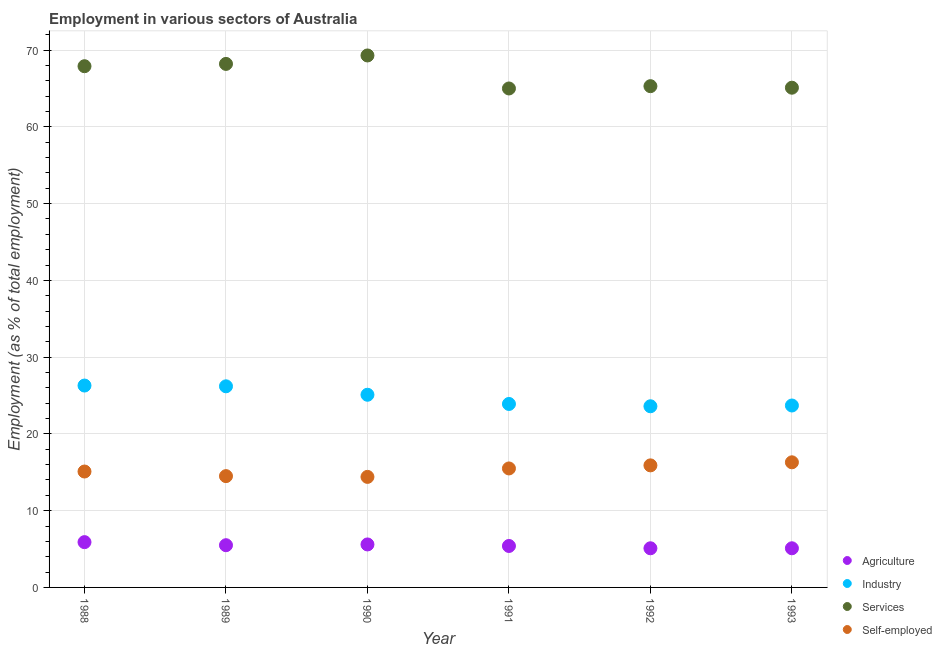How many different coloured dotlines are there?
Give a very brief answer. 4. What is the percentage of self employed workers in 1993?
Offer a terse response. 16.3. Across all years, what is the maximum percentage of self employed workers?
Make the answer very short. 16.3. Across all years, what is the minimum percentage of self employed workers?
Offer a terse response. 14.4. In which year was the percentage of self employed workers minimum?
Your answer should be very brief. 1990. What is the total percentage of workers in agriculture in the graph?
Keep it short and to the point. 32.6. What is the difference between the percentage of self employed workers in 1991 and that in 1993?
Provide a succinct answer. -0.8. What is the difference between the percentage of workers in industry in 1991 and the percentage of self employed workers in 1992?
Offer a very short reply. 8. What is the average percentage of workers in agriculture per year?
Give a very brief answer. 5.43. In the year 1991, what is the difference between the percentage of workers in agriculture and percentage of workers in services?
Your response must be concise. -59.6. In how many years, is the percentage of workers in services greater than 40 %?
Make the answer very short. 6. What is the ratio of the percentage of self employed workers in 1991 to that in 1993?
Your answer should be compact. 0.95. Is the difference between the percentage of workers in services in 1989 and 1990 greater than the difference between the percentage of self employed workers in 1989 and 1990?
Provide a short and direct response. No. What is the difference between the highest and the second highest percentage of self employed workers?
Ensure brevity in your answer.  0.4. What is the difference between the highest and the lowest percentage of workers in industry?
Provide a succinct answer. 2.7. In how many years, is the percentage of workers in agriculture greater than the average percentage of workers in agriculture taken over all years?
Your response must be concise. 3. Is the sum of the percentage of self employed workers in 1992 and 1993 greater than the maximum percentage of workers in services across all years?
Keep it short and to the point. No. Is it the case that in every year, the sum of the percentage of self employed workers and percentage of workers in agriculture is greater than the sum of percentage of workers in industry and percentage of workers in services?
Ensure brevity in your answer.  No. Is it the case that in every year, the sum of the percentage of workers in agriculture and percentage of workers in industry is greater than the percentage of workers in services?
Your answer should be very brief. No. Does the percentage of workers in services monotonically increase over the years?
Offer a very short reply. No. Is the percentage of workers in services strictly greater than the percentage of self employed workers over the years?
Your response must be concise. Yes. What is the difference between two consecutive major ticks on the Y-axis?
Ensure brevity in your answer.  10. Are the values on the major ticks of Y-axis written in scientific E-notation?
Keep it short and to the point. No. Where does the legend appear in the graph?
Your response must be concise. Bottom right. How are the legend labels stacked?
Your response must be concise. Vertical. What is the title of the graph?
Your response must be concise. Employment in various sectors of Australia. What is the label or title of the X-axis?
Give a very brief answer. Year. What is the label or title of the Y-axis?
Offer a terse response. Employment (as % of total employment). What is the Employment (as % of total employment) of Agriculture in 1988?
Offer a very short reply. 5.9. What is the Employment (as % of total employment) in Industry in 1988?
Your answer should be very brief. 26.3. What is the Employment (as % of total employment) of Services in 1988?
Offer a terse response. 67.9. What is the Employment (as % of total employment) in Self-employed in 1988?
Provide a short and direct response. 15.1. What is the Employment (as % of total employment) in Industry in 1989?
Your response must be concise. 26.2. What is the Employment (as % of total employment) in Services in 1989?
Ensure brevity in your answer.  68.2. What is the Employment (as % of total employment) in Agriculture in 1990?
Your answer should be very brief. 5.6. What is the Employment (as % of total employment) in Industry in 1990?
Offer a very short reply. 25.1. What is the Employment (as % of total employment) in Services in 1990?
Offer a terse response. 69.3. What is the Employment (as % of total employment) in Self-employed in 1990?
Keep it short and to the point. 14.4. What is the Employment (as % of total employment) of Agriculture in 1991?
Your answer should be compact. 5.4. What is the Employment (as % of total employment) of Industry in 1991?
Provide a short and direct response. 23.9. What is the Employment (as % of total employment) in Self-employed in 1991?
Your answer should be compact. 15.5. What is the Employment (as % of total employment) of Agriculture in 1992?
Provide a short and direct response. 5.1. What is the Employment (as % of total employment) of Industry in 1992?
Provide a short and direct response. 23.6. What is the Employment (as % of total employment) in Services in 1992?
Your response must be concise. 65.3. What is the Employment (as % of total employment) of Self-employed in 1992?
Your answer should be compact. 15.9. What is the Employment (as % of total employment) in Agriculture in 1993?
Your answer should be very brief. 5.1. What is the Employment (as % of total employment) in Industry in 1993?
Provide a succinct answer. 23.7. What is the Employment (as % of total employment) in Services in 1993?
Make the answer very short. 65.1. What is the Employment (as % of total employment) of Self-employed in 1993?
Your answer should be compact. 16.3. Across all years, what is the maximum Employment (as % of total employment) of Agriculture?
Keep it short and to the point. 5.9. Across all years, what is the maximum Employment (as % of total employment) in Industry?
Make the answer very short. 26.3. Across all years, what is the maximum Employment (as % of total employment) in Services?
Keep it short and to the point. 69.3. Across all years, what is the maximum Employment (as % of total employment) in Self-employed?
Your answer should be compact. 16.3. Across all years, what is the minimum Employment (as % of total employment) in Agriculture?
Ensure brevity in your answer.  5.1. Across all years, what is the minimum Employment (as % of total employment) in Industry?
Your answer should be compact. 23.6. Across all years, what is the minimum Employment (as % of total employment) of Self-employed?
Offer a very short reply. 14.4. What is the total Employment (as % of total employment) in Agriculture in the graph?
Your response must be concise. 32.6. What is the total Employment (as % of total employment) of Industry in the graph?
Ensure brevity in your answer.  148.8. What is the total Employment (as % of total employment) of Services in the graph?
Make the answer very short. 400.8. What is the total Employment (as % of total employment) of Self-employed in the graph?
Offer a very short reply. 91.7. What is the difference between the Employment (as % of total employment) of Agriculture in 1988 and that in 1989?
Ensure brevity in your answer.  0.4. What is the difference between the Employment (as % of total employment) in Services in 1988 and that in 1989?
Your answer should be compact. -0.3. What is the difference between the Employment (as % of total employment) of Agriculture in 1988 and that in 1990?
Provide a succinct answer. 0.3. What is the difference between the Employment (as % of total employment) in Industry in 1988 and that in 1990?
Offer a terse response. 1.2. What is the difference between the Employment (as % of total employment) of Services in 1988 and that in 1990?
Ensure brevity in your answer.  -1.4. What is the difference between the Employment (as % of total employment) in Self-employed in 1988 and that in 1992?
Provide a succinct answer. -0.8. What is the difference between the Employment (as % of total employment) of Agriculture in 1988 and that in 1993?
Offer a terse response. 0.8. What is the difference between the Employment (as % of total employment) of Industry in 1988 and that in 1993?
Offer a very short reply. 2.6. What is the difference between the Employment (as % of total employment) of Services in 1988 and that in 1993?
Your response must be concise. 2.8. What is the difference between the Employment (as % of total employment) in Agriculture in 1989 and that in 1990?
Provide a short and direct response. -0.1. What is the difference between the Employment (as % of total employment) of Services in 1989 and that in 1990?
Give a very brief answer. -1.1. What is the difference between the Employment (as % of total employment) in Agriculture in 1989 and that in 1991?
Offer a terse response. 0.1. What is the difference between the Employment (as % of total employment) of Industry in 1989 and that in 1991?
Provide a short and direct response. 2.3. What is the difference between the Employment (as % of total employment) of Self-employed in 1989 and that in 1991?
Ensure brevity in your answer.  -1. What is the difference between the Employment (as % of total employment) in Agriculture in 1989 and that in 1992?
Your answer should be compact. 0.4. What is the difference between the Employment (as % of total employment) of Industry in 1989 and that in 1992?
Your answer should be very brief. 2.6. What is the difference between the Employment (as % of total employment) in Self-employed in 1989 and that in 1992?
Your answer should be very brief. -1.4. What is the difference between the Employment (as % of total employment) of Self-employed in 1989 and that in 1993?
Provide a succinct answer. -1.8. What is the difference between the Employment (as % of total employment) of Industry in 1990 and that in 1991?
Your answer should be very brief. 1.2. What is the difference between the Employment (as % of total employment) of Industry in 1990 and that in 1992?
Ensure brevity in your answer.  1.5. What is the difference between the Employment (as % of total employment) of Services in 1990 and that in 1992?
Ensure brevity in your answer.  4. What is the difference between the Employment (as % of total employment) of Industry in 1990 and that in 1993?
Your answer should be compact. 1.4. What is the difference between the Employment (as % of total employment) of Services in 1990 and that in 1993?
Offer a very short reply. 4.2. What is the difference between the Employment (as % of total employment) of Industry in 1991 and that in 1993?
Provide a succinct answer. 0.2. What is the difference between the Employment (as % of total employment) of Services in 1991 and that in 1993?
Offer a terse response. -0.1. What is the difference between the Employment (as % of total employment) in Agriculture in 1992 and that in 1993?
Ensure brevity in your answer.  0. What is the difference between the Employment (as % of total employment) of Services in 1992 and that in 1993?
Keep it short and to the point. 0.2. What is the difference between the Employment (as % of total employment) in Agriculture in 1988 and the Employment (as % of total employment) in Industry in 1989?
Make the answer very short. -20.3. What is the difference between the Employment (as % of total employment) of Agriculture in 1988 and the Employment (as % of total employment) of Services in 1989?
Your response must be concise. -62.3. What is the difference between the Employment (as % of total employment) of Industry in 1988 and the Employment (as % of total employment) of Services in 1989?
Offer a terse response. -41.9. What is the difference between the Employment (as % of total employment) in Services in 1988 and the Employment (as % of total employment) in Self-employed in 1989?
Give a very brief answer. 53.4. What is the difference between the Employment (as % of total employment) in Agriculture in 1988 and the Employment (as % of total employment) in Industry in 1990?
Keep it short and to the point. -19.2. What is the difference between the Employment (as % of total employment) in Agriculture in 1988 and the Employment (as % of total employment) in Services in 1990?
Your response must be concise. -63.4. What is the difference between the Employment (as % of total employment) in Agriculture in 1988 and the Employment (as % of total employment) in Self-employed in 1990?
Your response must be concise. -8.5. What is the difference between the Employment (as % of total employment) in Industry in 1988 and the Employment (as % of total employment) in Services in 1990?
Give a very brief answer. -43. What is the difference between the Employment (as % of total employment) in Industry in 1988 and the Employment (as % of total employment) in Self-employed in 1990?
Provide a succinct answer. 11.9. What is the difference between the Employment (as % of total employment) in Services in 1988 and the Employment (as % of total employment) in Self-employed in 1990?
Your answer should be very brief. 53.5. What is the difference between the Employment (as % of total employment) in Agriculture in 1988 and the Employment (as % of total employment) in Services in 1991?
Keep it short and to the point. -59.1. What is the difference between the Employment (as % of total employment) in Industry in 1988 and the Employment (as % of total employment) in Services in 1991?
Your response must be concise. -38.7. What is the difference between the Employment (as % of total employment) of Industry in 1988 and the Employment (as % of total employment) of Self-employed in 1991?
Keep it short and to the point. 10.8. What is the difference between the Employment (as % of total employment) of Services in 1988 and the Employment (as % of total employment) of Self-employed in 1991?
Your response must be concise. 52.4. What is the difference between the Employment (as % of total employment) of Agriculture in 1988 and the Employment (as % of total employment) of Industry in 1992?
Give a very brief answer. -17.7. What is the difference between the Employment (as % of total employment) in Agriculture in 1988 and the Employment (as % of total employment) in Services in 1992?
Give a very brief answer. -59.4. What is the difference between the Employment (as % of total employment) of Agriculture in 1988 and the Employment (as % of total employment) of Self-employed in 1992?
Make the answer very short. -10. What is the difference between the Employment (as % of total employment) of Industry in 1988 and the Employment (as % of total employment) of Services in 1992?
Ensure brevity in your answer.  -39. What is the difference between the Employment (as % of total employment) of Industry in 1988 and the Employment (as % of total employment) of Self-employed in 1992?
Keep it short and to the point. 10.4. What is the difference between the Employment (as % of total employment) of Agriculture in 1988 and the Employment (as % of total employment) of Industry in 1993?
Keep it short and to the point. -17.8. What is the difference between the Employment (as % of total employment) of Agriculture in 1988 and the Employment (as % of total employment) of Services in 1993?
Provide a short and direct response. -59.2. What is the difference between the Employment (as % of total employment) of Agriculture in 1988 and the Employment (as % of total employment) of Self-employed in 1993?
Offer a terse response. -10.4. What is the difference between the Employment (as % of total employment) in Industry in 1988 and the Employment (as % of total employment) in Services in 1993?
Provide a succinct answer. -38.8. What is the difference between the Employment (as % of total employment) of Services in 1988 and the Employment (as % of total employment) of Self-employed in 1993?
Give a very brief answer. 51.6. What is the difference between the Employment (as % of total employment) of Agriculture in 1989 and the Employment (as % of total employment) of Industry in 1990?
Ensure brevity in your answer.  -19.6. What is the difference between the Employment (as % of total employment) in Agriculture in 1989 and the Employment (as % of total employment) in Services in 1990?
Your answer should be compact. -63.8. What is the difference between the Employment (as % of total employment) in Industry in 1989 and the Employment (as % of total employment) in Services in 1990?
Keep it short and to the point. -43.1. What is the difference between the Employment (as % of total employment) in Industry in 1989 and the Employment (as % of total employment) in Self-employed in 1990?
Give a very brief answer. 11.8. What is the difference between the Employment (as % of total employment) of Services in 1989 and the Employment (as % of total employment) of Self-employed in 1990?
Give a very brief answer. 53.8. What is the difference between the Employment (as % of total employment) of Agriculture in 1989 and the Employment (as % of total employment) of Industry in 1991?
Provide a succinct answer. -18.4. What is the difference between the Employment (as % of total employment) of Agriculture in 1989 and the Employment (as % of total employment) of Services in 1991?
Provide a succinct answer. -59.5. What is the difference between the Employment (as % of total employment) in Industry in 1989 and the Employment (as % of total employment) in Services in 1991?
Keep it short and to the point. -38.8. What is the difference between the Employment (as % of total employment) in Industry in 1989 and the Employment (as % of total employment) in Self-employed in 1991?
Your answer should be compact. 10.7. What is the difference between the Employment (as % of total employment) in Services in 1989 and the Employment (as % of total employment) in Self-employed in 1991?
Provide a succinct answer. 52.7. What is the difference between the Employment (as % of total employment) of Agriculture in 1989 and the Employment (as % of total employment) of Industry in 1992?
Provide a succinct answer. -18.1. What is the difference between the Employment (as % of total employment) of Agriculture in 1989 and the Employment (as % of total employment) of Services in 1992?
Give a very brief answer. -59.8. What is the difference between the Employment (as % of total employment) in Industry in 1989 and the Employment (as % of total employment) in Services in 1992?
Offer a very short reply. -39.1. What is the difference between the Employment (as % of total employment) of Services in 1989 and the Employment (as % of total employment) of Self-employed in 1992?
Make the answer very short. 52.3. What is the difference between the Employment (as % of total employment) in Agriculture in 1989 and the Employment (as % of total employment) in Industry in 1993?
Your response must be concise. -18.2. What is the difference between the Employment (as % of total employment) of Agriculture in 1989 and the Employment (as % of total employment) of Services in 1993?
Keep it short and to the point. -59.6. What is the difference between the Employment (as % of total employment) in Industry in 1989 and the Employment (as % of total employment) in Services in 1993?
Your response must be concise. -38.9. What is the difference between the Employment (as % of total employment) of Industry in 1989 and the Employment (as % of total employment) of Self-employed in 1993?
Provide a succinct answer. 9.9. What is the difference between the Employment (as % of total employment) in Services in 1989 and the Employment (as % of total employment) in Self-employed in 1993?
Give a very brief answer. 51.9. What is the difference between the Employment (as % of total employment) in Agriculture in 1990 and the Employment (as % of total employment) in Industry in 1991?
Provide a short and direct response. -18.3. What is the difference between the Employment (as % of total employment) of Agriculture in 1990 and the Employment (as % of total employment) of Services in 1991?
Your answer should be very brief. -59.4. What is the difference between the Employment (as % of total employment) in Industry in 1990 and the Employment (as % of total employment) in Services in 1991?
Your answer should be compact. -39.9. What is the difference between the Employment (as % of total employment) of Services in 1990 and the Employment (as % of total employment) of Self-employed in 1991?
Provide a short and direct response. 53.8. What is the difference between the Employment (as % of total employment) of Agriculture in 1990 and the Employment (as % of total employment) of Services in 1992?
Keep it short and to the point. -59.7. What is the difference between the Employment (as % of total employment) in Agriculture in 1990 and the Employment (as % of total employment) in Self-employed in 1992?
Ensure brevity in your answer.  -10.3. What is the difference between the Employment (as % of total employment) of Industry in 1990 and the Employment (as % of total employment) of Services in 1992?
Give a very brief answer. -40.2. What is the difference between the Employment (as % of total employment) of Services in 1990 and the Employment (as % of total employment) of Self-employed in 1992?
Make the answer very short. 53.4. What is the difference between the Employment (as % of total employment) of Agriculture in 1990 and the Employment (as % of total employment) of Industry in 1993?
Your answer should be very brief. -18.1. What is the difference between the Employment (as % of total employment) of Agriculture in 1990 and the Employment (as % of total employment) of Services in 1993?
Offer a very short reply. -59.5. What is the difference between the Employment (as % of total employment) of Agriculture in 1990 and the Employment (as % of total employment) of Self-employed in 1993?
Offer a very short reply. -10.7. What is the difference between the Employment (as % of total employment) of Industry in 1990 and the Employment (as % of total employment) of Services in 1993?
Provide a short and direct response. -40. What is the difference between the Employment (as % of total employment) in Agriculture in 1991 and the Employment (as % of total employment) in Industry in 1992?
Ensure brevity in your answer.  -18.2. What is the difference between the Employment (as % of total employment) of Agriculture in 1991 and the Employment (as % of total employment) of Services in 1992?
Provide a succinct answer. -59.9. What is the difference between the Employment (as % of total employment) in Industry in 1991 and the Employment (as % of total employment) in Services in 1992?
Provide a succinct answer. -41.4. What is the difference between the Employment (as % of total employment) in Industry in 1991 and the Employment (as % of total employment) in Self-employed in 1992?
Your response must be concise. 8. What is the difference between the Employment (as % of total employment) of Services in 1991 and the Employment (as % of total employment) of Self-employed in 1992?
Give a very brief answer. 49.1. What is the difference between the Employment (as % of total employment) of Agriculture in 1991 and the Employment (as % of total employment) of Industry in 1993?
Offer a very short reply. -18.3. What is the difference between the Employment (as % of total employment) of Agriculture in 1991 and the Employment (as % of total employment) of Services in 1993?
Make the answer very short. -59.7. What is the difference between the Employment (as % of total employment) in Agriculture in 1991 and the Employment (as % of total employment) in Self-employed in 1993?
Offer a terse response. -10.9. What is the difference between the Employment (as % of total employment) of Industry in 1991 and the Employment (as % of total employment) of Services in 1993?
Provide a short and direct response. -41.2. What is the difference between the Employment (as % of total employment) in Services in 1991 and the Employment (as % of total employment) in Self-employed in 1993?
Offer a very short reply. 48.7. What is the difference between the Employment (as % of total employment) in Agriculture in 1992 and the Employment (as % of total employment) in Industry in 1993?
Keep it short and to the point. -18.6. What is the difference between the Employment (as % of total employment) of Agriculture in 1992 and the Employment (as % of total employment) of Services in 1993?
Offer a very short reply. -60. What is the difference between the Employment (as % of total employment) in Agriculture in 1992 and the Employment (as % of total employment) in Self-employed in 1993?
Provide a short and direct response. -11.2. What is the difference between the Employment (as % of total employment) in Industry in 1992 and the Employment (as % of total employment) in Services in 1993?
Keep it short and to the point. -41.5. What is the difference between the Employment (as % of total employment) in Industry in 1992 and the Employment (as % of total employment) in Self-employed in 1993?
Ensure brevity in your answer.  7.3. What is the average Employment (as % of total employment) in Agriculture per year?
Give a very brief answer. 5.43. What is the average Employment (as % of total employment) in Industry per year?
Your response must be concise. 24.8. What is the average Employment (as % of total employment) of Services per year?
Keep it short and to the point. 66.8. What is the average Employment (as % of total employment) of Self-employed per year?
Provide a short and direct response. 15.28. In the year 1988, what is the difference between the Employment (as % of total employment) in Agriculture and Employment (as % of total employment) in Industry?
Offer a very short reply. -20.4. In the year 1988, what is the difference between the Employment (as % of total employment) of Agriculture and Employment (as % of total employment) of Services?
Your answer should be compact. -62. In the year 1988, what is the difference between the Employment (as % of total employment) of Industry and Employment (as % of total employment) of Services?
Make the answer very short. -41.6. In the year 1988, what is the difference between the Employment (as % of total employment) of Industry and Employment (as % of total employment) of Self-employed?
Provide a succinct answer. 11.2. In the year 1988, what is the difference between the Employment (as % of total employment) in Services and Employment (as % of total employment) in Self-employed?
Your response must be concise. 52.8. In the year 1989, what is the difference between the Employment (as % of total employment) of Agriculture and Employment (as % of total employment) of Industry?
Your response must be concise. -20.7. In the year 1989, what is the difference between the Employment (as % of total employment) in Agriculture and Employment (as % of total employment) in Services?
Your answer should be compact. -62.7. In the year 1989, what is the difference between the Employment (as % of total employment) in Agriculture and Employment (as % of total employment) in Self-employed?
Your answer should be compact. -9. In the year 1989, what is the difference between the Employment (as % of total employment) in Industry and Employment (as % of total employment) in Services?
Your answer should be very brief. -42. In the year 1989, what is the difference between the Employment (as % of total employment) in Industry and Employment (as % of total employment) in Self-employed?
Your response must be concise. 11.7. In the year 1989, what is the difference between the Employment (as % of total employment) in Services and Employment (as % of total employment) in Self-employed?
Offer a very short reply. 53.7. In the year 1990, what is the difference between the Employment (as % of total employment) of Agriculture and Employment (as % of total employment) of Industry?
Your response must be concise. -19.5. In the year 1990, what is the difference between the Employment (as % of total employment) in Agriculture and Employment (as % of total employment) in Services?
Give a very brief answer. -63.7. In the year 1990, what is the difference between the Employment (as % of total employment) in Agriculture and Employment (as % of total employment) in Self-employed?
Ensure brevity in your answer.  -8.8. In the year 1990, what is the difference between the Employment (as % of total employment) of Industry and Employment (as % of total employment) of Services?
Your answer should be compact. -44.2. In the year 1990, what is the difference between the Employment (as % of total employment) in Industry and Employment (as % of total employment) in Self-employed?
Your answer should be compact. 10.7. In the year 1990, what is the difference between the Employment (as % of total employment) in Services and Employment (as % of total employment) in Self-employed?
Keep it short and to the point. 54.9. In the year 1991, what is the difference between the Employment (as % of total employment) in Agriculture and Employment (as % of total employment) in Industry?
Provide a succinct answer. -18.5. In the year 1991, what is the difference between the Employment (as % of total employment) of Agriculture and Employment (as % of total employment) of Services?
Your answer should be very brief. -59.6. In the year 1991, what is the difference between the Employment (as % of total employment) in Agriculture and Employment (as % of total employment) in Self-employed?
Make the answer very short. -10.1. In the year 1991, what is the difference between the Employment (as % of total employment) in Industry and Employment (as % of total employment) in Services?
Your answer should be very brief. -41.1. In the year 1991, what is the difference between the Employment (as % of total employment) in Industry and Employment (as % of total employment) in Self-employed?
Your response must be concise. 8.4. In the year 1991, what is the difference between the Employment (as % of total employment) of Services and Employment (as % of total employment) of Self-employed?
Keep it short and to the point. 49.5. In the year 1992, what is the difference between the Employment (as % of total employment) of Agriculture and Employment (as % of total employment) of Industry?
Make the answer very short. -18.5. In the year 1992, what is the difference between the Employment (as % of total employment) of Agriculture and Employment (as % of total employment) of Services?
Keep it short and to the point. -60.2. In the year 1992, what is the difference between the Employment (as % of total employment) in Agriculture and Employment (as % of total employment) in Self-employed?
Make the answer very short. -10.8. In the year 1992, what is the difference between the Employment (as % of total employment) in Industry and Employment (as % of total employment) in Services?
Provide a succinct answer. -41.7. In the year 1992, what is the difference between the Employment (as % of total employment) of Industry and Employment (as % of total employment) of Self-employed?
Your answer should be compact. 7.7. In the year 1992, what is the difference between the Employment (as % of total employment) in Services and Employment (as % of total employment) in Self-employed?
Your answer should be very brief. 49.4. In the year 1993, what is the difference between the Employment (as % of total employment) of Agriculture and Employment (as % of total employment) of Industry?
Your response must be concise. -18.6. In the year 1993, what is the difference between the Employment (as % of total employment) in Agriculture and Employment (as % of total employment) in Services?
Offer a terse response. -60. In the year 1993, what is the difference between the Employment (as % of total employment) in Industry and Employment (as % of total employment) in Services?
Your answer should be very brief. -41.4. In the year 1993, what is the difference between the Employment (as % of total employment) in Industry and Employment (as % of total employment) in Self-employed?
Provide a succinct answer. 7.4. In the year 1993, what is the difference between the Employment (as % of total employment) in Services and Employment (as % of total employment) in Self-employed?
Make the answer very short. 48.8. What is the ratio of the Employment (as % of total employment) in Agriculture in 1988 to that in 1989?
Provide a short and direct response. 1.07. What is the ratio of the Employment (as % of total employment) of Self-employed in 1988 to that in 1989?
Your answer should be very brief. 1.04. What is the ratio of the Employment (as % of total employment) of Agriculture in 1988 to that in 1990?
Give a very brief answer. 1.05. What is the ratio of the Employment (as % of total employment) of Industry in 1988 to that in 1990?
Give a very brief answer. 1.05. What is the ratio of the Employment (as % of total employment) in Services in 1988 to that in 1990?
Provide a short and direct response. 0.98. What is the ratio of the Employment (as % of total employment) of Self-employed in 1988 to that in 1990?
Give a very brief answer. 1.05. What is the ratio of the Employment (as % of total employment) of Agriculture in 1988 to that in 1991?
Offer a very short reply. 1.09. What is the ratio of the Employment (as % of total employment) in Industry in 1988 to that in 1991?
Offer a terse response. 1.1. What is the ratio of the Employment (as % of total employment) of Services in 1988 to that in 1991?
Offer a terse response. 1.04. What is the ratio of the Employment (as % of total employment) in Self-employed in 1988 to that in 1991?
Ensure brevity in your answer.  0.97. What is the ratio of the Employment (as % of total employment) in Agriculture in 1988 to that in 1992?
Your answer should be very brief. 1.16. What is the ratio of the Employment (as % of total employment) of Industry in 1988 to that in 1992?
Provide a short and direct response. 1.11. What is the ratio of the Employment (as % of total employment) in Services in 1988 to that in 1992?
Keep it short and to the point. 1.04. What is the ratio of the Employment (as % of total employment) in Self-employed in 1988 to that in 1992?
Your answer should be very brief. 0.95. What is the ratio of the Employment (as % of total employment) in Agriculture in 1988 to that in 1993?
Make the answer very short. 1.16. What is the ratio of the Employment (as % of total employment) of Industry in 1988 to that in 1993?
Provide a short and direct response. 1.11. What is the ratio of the Employment (as % of total employment) of Services in 1988 to that in 1993?
Your response must be concise. 1.04. What is the ratio of the Employment (as % of total employment) of Self-employed in 1988 to that in 1993?
Ensure brevity in your answer.  0.93. What is the ratio of the Employment (as % of total employment) of Agriculture in 1989 to that in 1990?
Keep it short and to the point. 0.98. What is the ratio of the Employment (as % of total employment) in Industry in 1989 to that in 1990?
Your answer should be very brief. 1.04. What is the ratio of the Employment (as % of total employment) in Services in 1989 to that in 1990?
Make the answer very short. 0.98. What is the ratio of the Employment (as % of total employment) of Self-employed in 1989 to that in 1990?
Provide a succinct answer. 1.01. What is the ratio of the Employment (as % of total employment) in Agriculture in 1989 to that in 1991?
Provide a short and direct response. 1.02. What is the ratio of the Employment (as % of total employment) of Industry in 1989 to that in 1991?
Give a very brief answer. 1.1. What is the ratio of the Employment (as % of total employment) in Services in 1989 to that in 1991?
Your answer should be very brief. 1.05. What is the ratio of the Employment (as % of total employment) of Self-employed in 1989 to that in 1991?
Ensure brevity in your answer.  0.94. What is the ratio of the Employment (as % of total employment) of Agriculture in 1989 to that in 1992?
Give a very brief answer. 1.08. What is the ratio of the Employment (as % of total employment) in Industry in 1989 to that in 1992?
Provide a short and direct response. 1.11. What is the ratio of the Employment (as % of total employment) in Services in 1989 to that in 1992?
Keep it short and to the point. 1.04. What is the ratio of the Employment (as % of total employment) of Self-employed in 1989 to that in 1992?
Keep it short and to the point. 0.91. What is the ratio of the Employment (as % of total employment) of Agriculture in 1989 to that in 1993?
Give a very brief answer. 1.08. What is the ratio of the Employment (as % of total employment) in Industry in 1989 to that in 1993?
Make the answer very short. 1.11. What is the ratio of the Employment (as % of total employment) of Services in 1989 to that in 1993?
Your answer should be compact. 1.05. What is the ratio of the Employment (as % of total employment) of Self-employed in 1989 to that in 1993?
Provide a succinct answer. 0.89. What is the ratio of the Employment (as % of total employment) of Industry in 1990 to that in 1991?
Offer a very short reply. 1.05. What is the ratio of the Employment (as % of total employment) in Services in 1990 to that in 1991?
Offer a terse response. 1.07. What is the ratio of the Employment (as % of total employment) in Self-employed in 1990 to that in 1991?
Offer a very short reply. 0.93. What is the ratio of the Employment (as % of total employment) of Agriculture in 1990 to that in 1992?
Ensure brevity in your answer.  1.1. What is the ratio of the Employment (as % of total employment) in Industry in 1990 to that in 1992?
Make the answer very short. 1.06. What is the ratio of the Employment (as % of total employment) of Services in 1990 to that in 1992?
Provide a short and direct response. 1.06. What is the ratio of the Employment (as % of total employment) of Self-employed in 1990 to that in 1992?
Offer a very short reply. 0.91. What is the ratio of the Employment (as % of total employment) of Agriculture in 1990 to that in 1993?
Your response must be concise. 1.1. What is the ratio of the Employment (as % of total employment) of Industry in 1990 to that in 1993?
Give a very brief answer. 1.06. What is the ratio of the Employment (as % of total employment) of Services in 1990 to that in 1993?
Offer a terse response. 1.06. What is the ratio of the Employment (as % of total employment) in Self-employed in 1990 to that in 1993?
Provide a short and direct response. 0.88. What is the ratio of the Employment (as % of total employment) in Agriculture in 1991 to that in 1992?
Provide a succinct answer. 1.06. What is the ratio of the Employment (as % of total employment) of Industry in 1991 to that in 1992?
Ensure brevity in your answer.  1.01. What is the ratio of the Employment (as % of total employment) in Self-employed in 1991 to that in 1992?
Provide a succinct answer. 0.97. What is the ratio of the Employment (as % of total employment) of Agriculture in 1991 to that in 1993?
Provide a succinct answer. 1.06. What is the ratio of the Employment (as % of total employment) in Industry in 1991 to that in 1993?
Provide a short and direct response. 1.01. What is the ratio of the Employment (as % of total employment) in Services in 1991 to that in 1993?
Provide a succinct answer. 1. What is the ratio of the Employment (as % of total employment) of Self-employed in 1991 to that in 1993?
Give a very brief answer. 0.95. What is the ratio of the Employment (as % of total employment) in Self-employed in 1992 to that in 1993?
Your answer should be compact. 0.98. What is the difference between the highest and the second highest Employment (as % of total employment) of Agriculture?
Make the answer very short. 0.3. What is the difference between the highest and the second highest Employment (as % of total employment) in Services?
Offer a terse response. 1.1. What is the difference between the highest and the second highest Employment (as % of total employment) in Self-employed?
Make the answer very short. 0.4. What is the difference between the highest and the lowest Employment (as % of total employment) in Agriculture?
Your response must be concise. 0.8. What is the difference between the highest and the lowest Employment (as % of total employment) of Industry?
Provide a succinct answer. 2.7. 